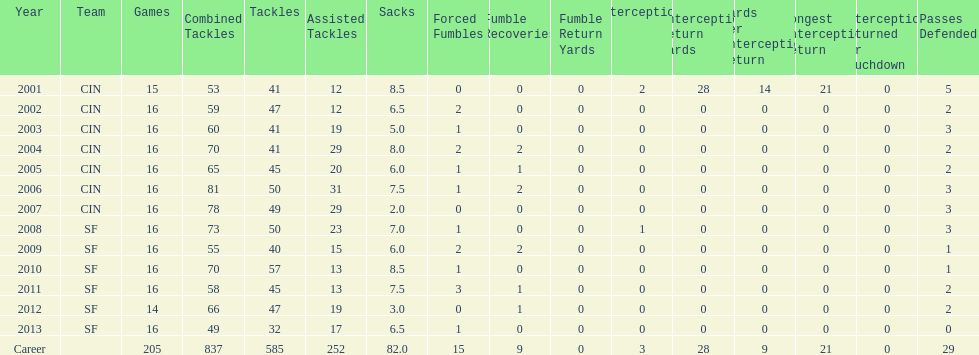For how many uninterrupted seasons has he played in sixteen games? 10. 